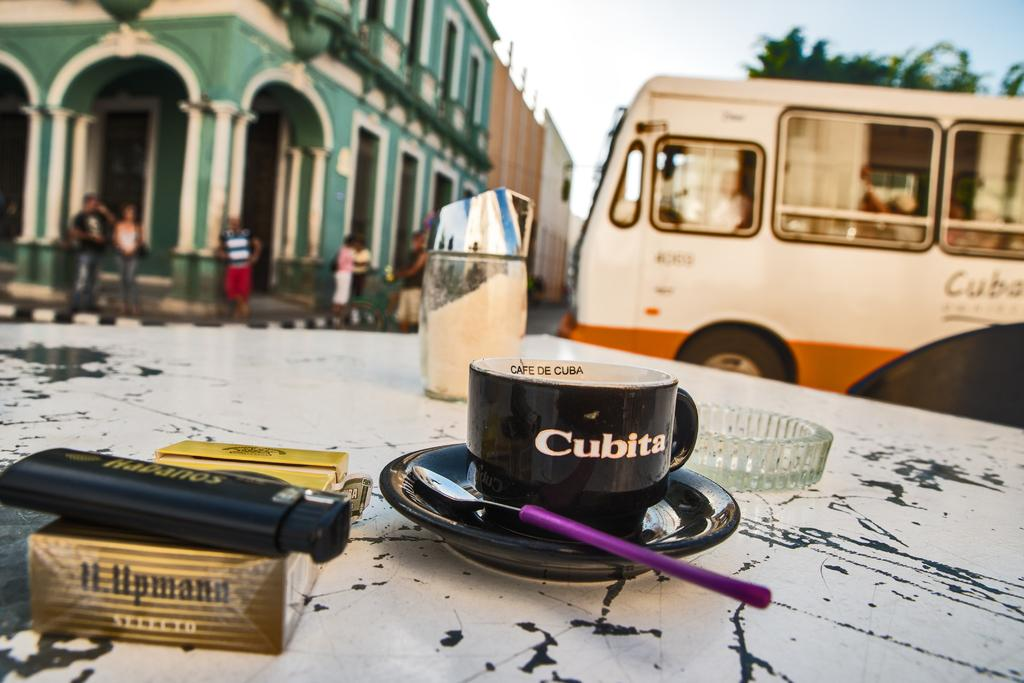What is the main object on the platform in the image? There is a cup present on the platform. What other items are on the platform? A saucer and a spoon are on the platform, along with other objects. What can be seen in the background of the image? There is a building, people, a vehicle, trees, and the sky visible in the background of the image. What type of rhythm can be heard coming from the market in the image? There is no market present in the image, and therefore no rhythm can be heard. 